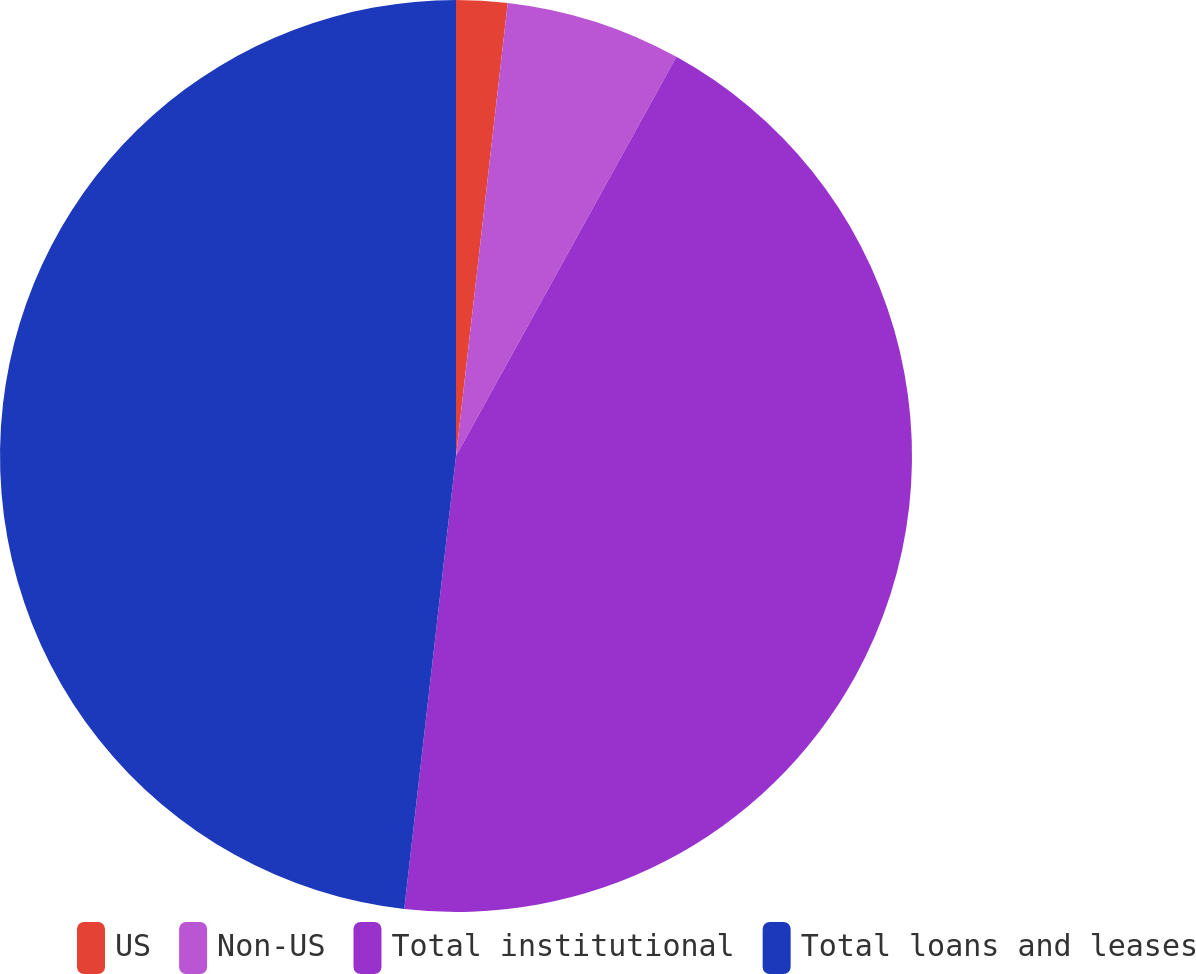Convert chart. <chart><loc_0><loc_0><loc_500><loc_500><pie_chart><fcel>US<fcel>Non-US<fcel>Total institutional<fcel>Total loans and leases<nl><fcel>1.81%<fcel>6.22%<fcel>43.78%<fcel>48.19%<nl></chart> 